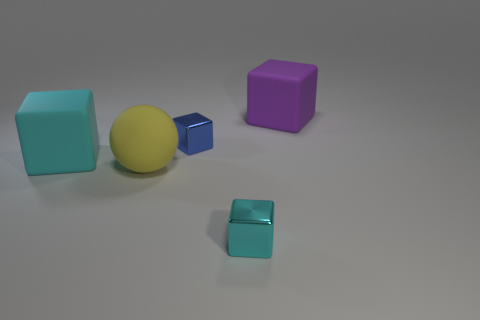Subtract all green blocks. Subtract all green spheres. How many blocks are left? 4 Add 3 large red spheres. How many objects exist? 8 Subtract all balls. How many objects are left? 4 Subtract 1 cyan cubes. How many objects are left? 4 Subtract all small cyan shiny spheres. Subtract all rubber things. How many objects are left? 2 Add 4 cyan metallic cubes. How many cyan metallic cubes are left? 5 Add 1 cyan matte blocks. How many cyan matte blocks exist? 2 